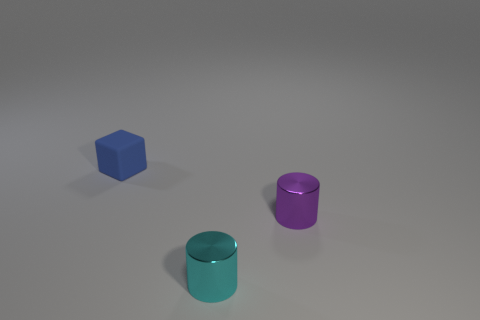Does the small blue thing have the same shape as the small cyan metal object?
Keep it short and to the point. No. What number of other objects are there of the same material as the cyan cylinder?
Your response must be concise. 1. How many tiny cyan objects are the same shape as the purple shiny thing?
Provide a short and direct response. 1. What is the color of the tiny object that is both on the right side of the small matte block and behind the cyan metallic cylinder?
Your answer should be very brief. Purple. What number of small metallic cylinders are there?
Give a very brief answer. 2. Does the matte cube have the same size as the purple metal cylinder?
Offer a very short reply. Yes. Is there a shiny cylinder of the same color as the tiny rubber block?
Offer a terse response. No. Do the thing that is in front of the purple metal cylinder and the small blue matte object have the same shape?
Offer a very short reply. No. What number of other blue matte objects are the same size as the blue object?
Provide a short and direct response. 0. There is a tiny shiny cylinder right of the tiny cyan shiny thing; how many purple objects are behind it?
Your response must be concise. 0. 